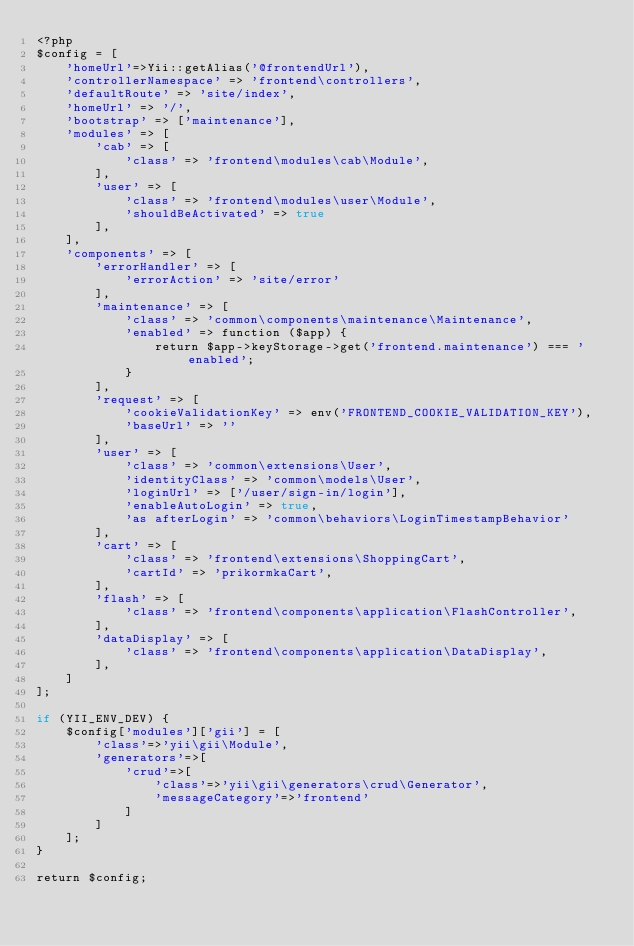Convert code to text. <code><loc_0><loc_0><loc_500><loc_500><_PHP_><?php
$config = [
    'homeUrl'=>Yii::getAlias('@frontendUrl'),
    'controllerNamespace' => 'frontend\controllers',
    'defaultRoute' => 'site/index',
    'homeUrl' => '/',
    'bootstrap' => ['maintenance'],
    'modules' => [
        'cab' => [
            'class' => 'frontend\modules\cab\Module',
        ],
        'user' => [
            'class' => 'frontend\modules\user\Module',
            'shouldBeActivated' => true
        ],
    ],
    'components' => [
        'errorHandler' => [
            'errorAction' => 'site/error'
        ],
        'maintenance' => [
            'class' => 'common\components\maintenance\Maintenance',
            'enabled' => function ($app) {
                return $app->keyStorage->get('frontend.maintenance') === 'enabled';
            }
        ],
        'request' => [
            'cookieValidationKey' => env('FRONTEND_COOKIE_VALIDATION_KEY'),
            'baseUrl' => ''
        ],
        'user' => [
            'class' => 'common\extensions\User',
            'identityClass' => 'common\models\User',
            'loginUrl' => ['/user/sign-in/login'],
            'enableAutoLogin' => true,
            'as afterLogin' => 'common\behaviors\LoginTimestampBehavior'
        ],
        'cart' => [
            'class' => 'frontend\extensions\ShoppingCart',
            'cartId' => 'prikormkaCart',
        ],
        'flash' => [
            'class' => 'frontend\components\application\FlashController',
        ],
        'dataDisplay' => [
            'class' => 'frontend\components\application\DataDisplay',
        ],
    ]
];

if (YII_ENV_DEV) {
    $config['modules']['gii'] = [
        'class'=>'yii\gii\Module',
        'generators'=>[
            'crud'=>[
                'class'=>'yii\gii\generators\crud\Generator',
                'messageCategory'=>'frontend'
            ]
        ]
    ];
}

return $config;
</code> 